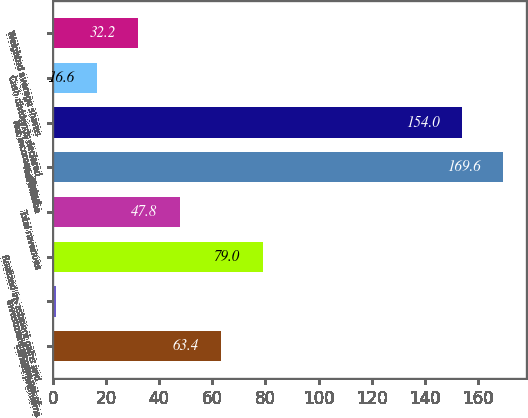Convert chart to OTSL. <chart><loc_0><loc_0><loc_500><loc_500><bar_chart><fcel>Earned premiums<fcel>Investment income net of<fcel>Realized investment gains and<fcel>Total revenues<fcel>Net income<fcel>Net income - diluted<fcel>Cash dividends declared<fcel>Weighted average shares<nl><fcel>63.4<fcel>1<fcel>79<fcel>47.8<fcel>169.6<fcel>154<fcel>16.6<fcel>32.2<nl></chart> 